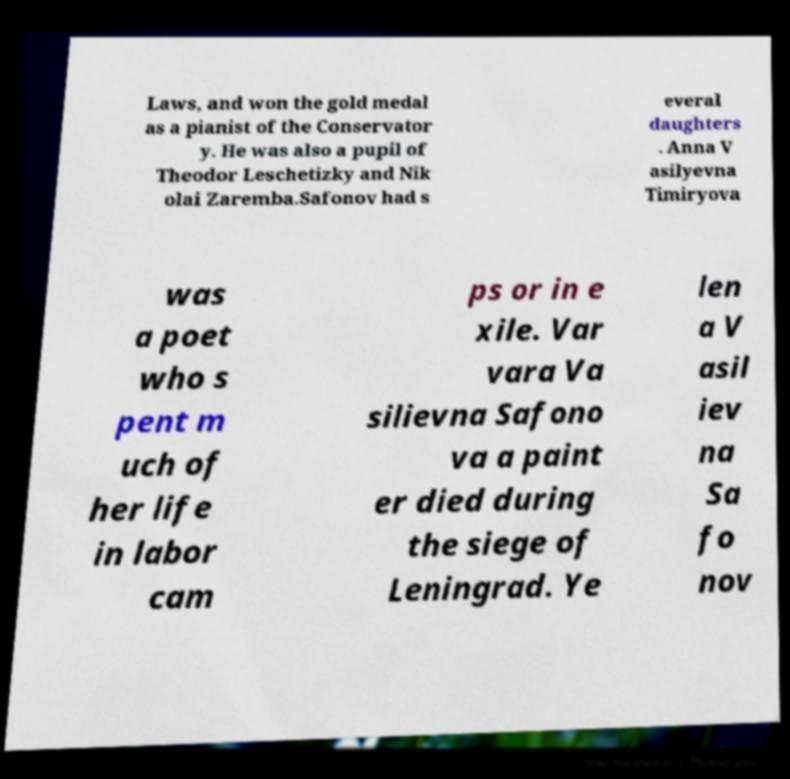Can you accurately transcribe the text from the provided image for me? Laws, and won the gold medal as a pianist of the Conservator y. He was also a pupil of Theodor Leschetizky and Nik olai Zaremba.Safonov had s everal daughters . Anna V asilyevna Timiryova was a poet who s pent m uch of her life in labor cam ps or in e xile. Var vara Va silievna Safono va a paint er died during the siege of Leningrad. Ye len a V asil iev na Sa fo nov 